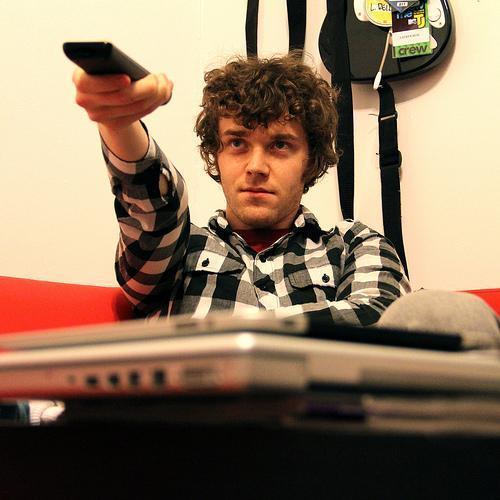How many people are in this picture?
Give a very brief answer. 1. How many hands do you see?
Give a very brief answer. 1. 